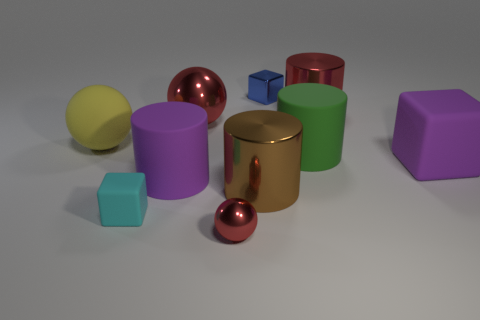Subtract 3 cylinders. How many cylinders are left? 1 Subtract all yellow cylinders. Subtract all gray blocks. How many cylinders are left? 4 Subtract all blocks. How many objects are left? 7 Add 1 tiny matte blocks. How many tiny matte blocks exist? 2 Subtract 0 gray cylinders. How many objects are left? 10 Subtract all rubber things. Subtract all small blue cubes. How many objects are left? 4 Add 3 yellow things. How many yellow things are left? 4 